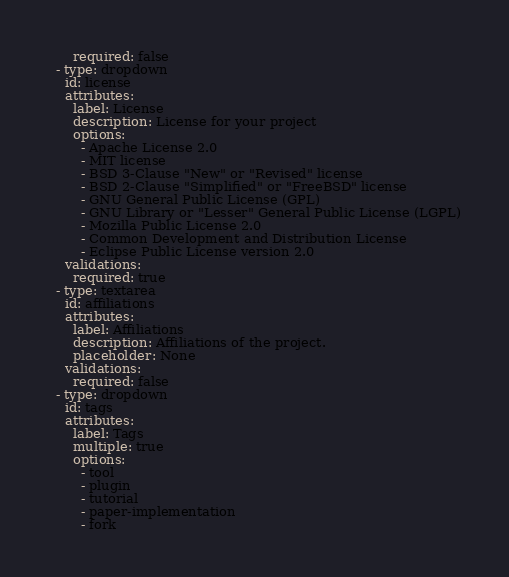Convert code to text. <code><loc_0><loc_0><loc_500><loc_500><_YAML_>      required: false
  - type: dropdown
    id: license
    attributes:
      label: License
      description: License for your project
      options:
        - Apache License 2.0
        - MIT license
        - BSD 3-Clause "New" or "Revised" license
        - BSD 2-Clause "Simplified" or "FreeBSD" license
        - GNU General Public License (GPL)
        - GNU Library or "Lesser" General Public License (LGPL)
        - Mozilla Public License 2.0
        - Common Development and Distribution License
        - Eclipse Public License version 2.0
    validations:
      required: true
  - type: textarea
    id: affiliations
    attributes:
      label: Affiliations
      description: Affiliations of the project.
      placeholder: None
    validations:
      required: false
  - type: dropdown
    id: tags
    attributes:
      label: Tags
      multiple: true
      options:
        - tool
        - plugin
        - tutorial
        - paper-implementation
        - fork
</code> 